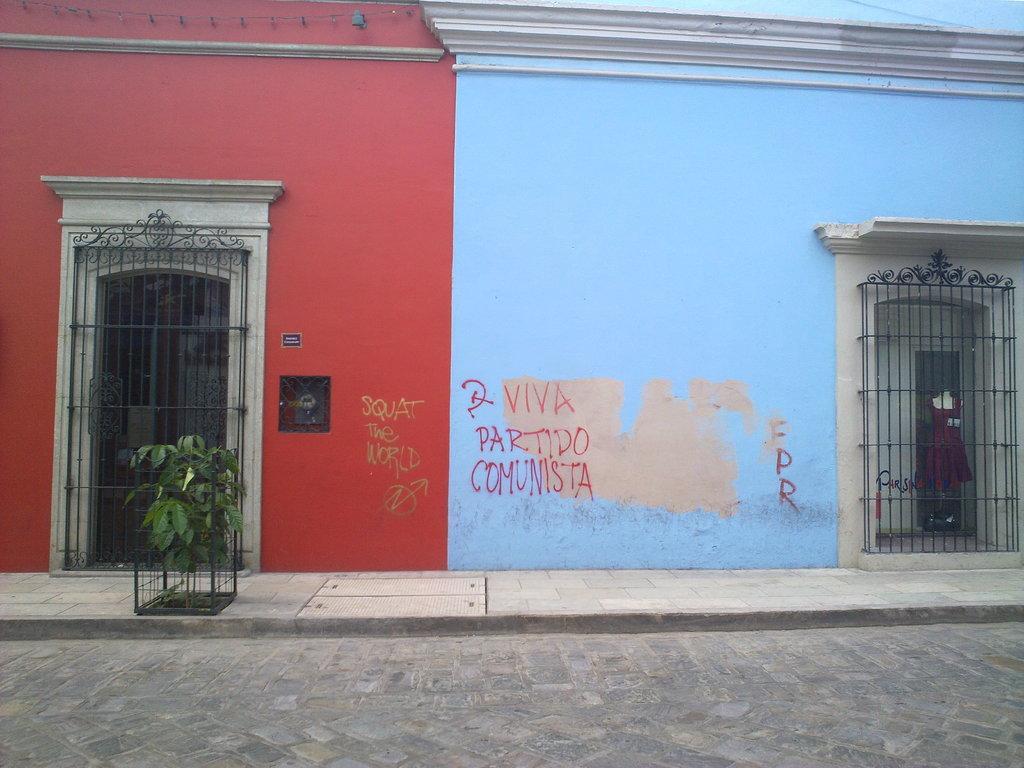Please provide a concise description of this image. In the picture I can see buildings. These buildings are red and blue in color. I can also see a plant, doors, something written on the wall and some other objects. 